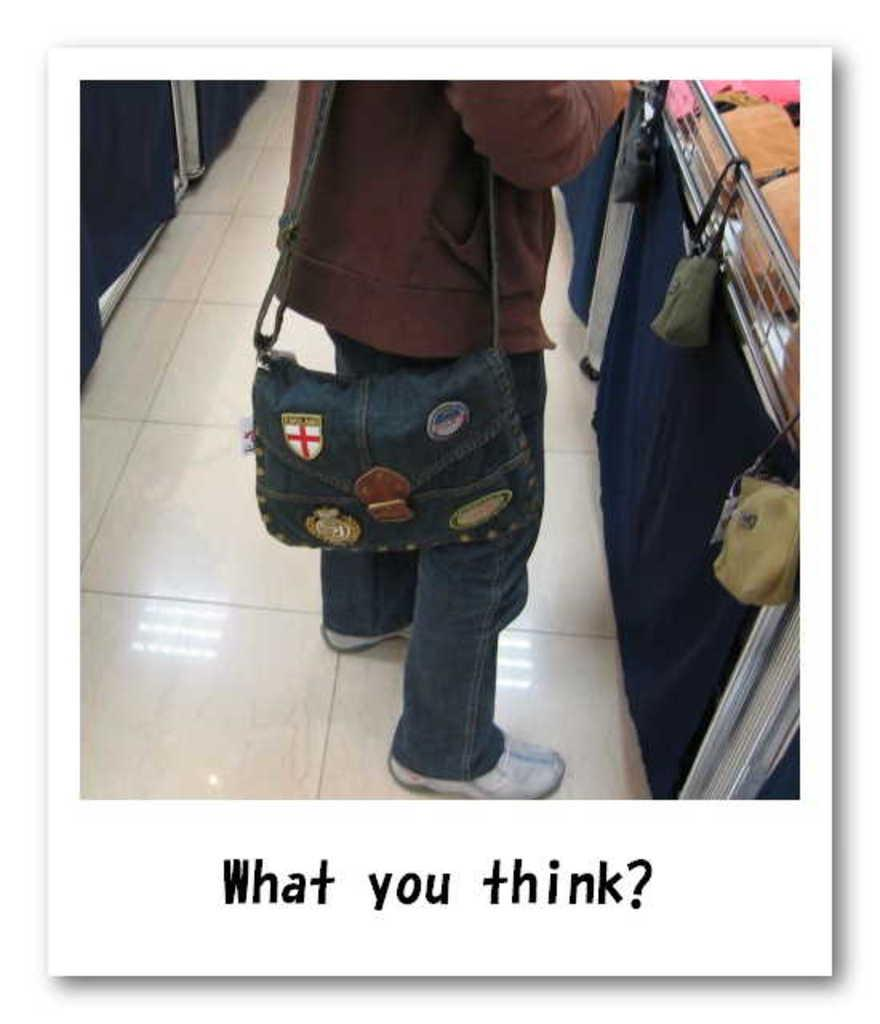Who is present in the image? There is a person in the image. What is the person holding in the image? The person is holding a bag. What is written on the bag? The phrase "what you think" is written on the bag. What color is the brick in the image? There is no brick present in the image. How does the development of the person in the image progress over time? The image only provides a snapshot of the person, so it is not possible to determine how their development progresses over time. 